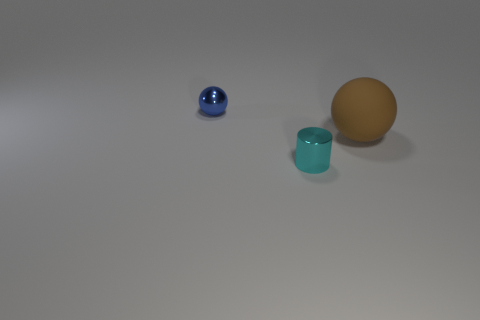What number of other objects are the same size as the cyan cylinder?
Your answer should be very brief. 1. Are there an equal number of large brown objects that are to the right of the tiny cyan metallic cylinder and small metal objects that are to the left of the brown thing?
Make the answer very short. No. Does the shiny thing in front of the rubber sphere have the same color as the sphere that is in front of the small ball?
Your response must be concise. No. Are there more small blue spheres that are behind the cyan object than brown things?
Give a very brief answer. No. What is the cylinder made of?
Keep it short and to the point. Metal. What shape is the other object that is the same material as the cyan object?
Your answer should be compact. Sphere. There is a cylinder in front of the tiny thing behind the brown object; what is its size?
Provide a short and direct response. Small. There is a small thing in front of the small blue thing; what color is it?
Give a very brief answer. Cyan. Are there any brown things of the same shape as the cyan object?
Provide a short and direct response. No. Is the number of brown rubber objects to the right of the small cylinder less than the number of big spheres that are right of the big sphere?
Make the answer very short. No. 